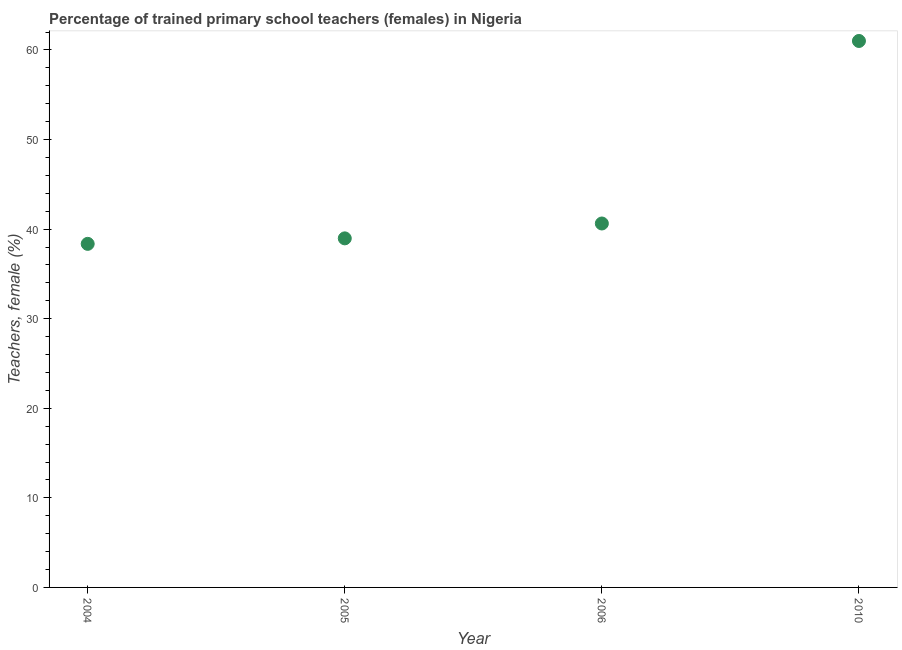What is the percentage of trained female teachers in 2005?
Ensure brevity in your answer.  38.97. Across all years, what is the maximum percentage of trained female teachers?
Offer a very short reply. 61.01. Across all years, what is the minimum percentage of trained female teachers?
Provide a short and direct response. 38.36. What is the sum of the percentage of trained female teachers?
Provide a succinct answer. 178.96. What is the difference between the percentage of trained female teachers in 2004 and 2010?
Give a very brief answer. -22.65. What is the average percentage of trained female teachers per year?
Give a very brief answer. 44.74. What is the median percentage of trained female teachers?
Keep it short and to the point. 39.8. In how many years, is the percentage of trained female teachers greater than 60 %?
Provide a short and direct response. 1. Do a majority of the years between 2004 and 2005 (inclusive) have percentage of trained female teachers greater than 12 %?
Ensure brevity in your answer.  Yes. What is the ratio of the percentage of trained female teachers in 2004 to that in 2005?
Keep it short and to the point. 0.98. Is the difference between the percentage of trained female teachers in 2005 and 2010 greater than the difference between any two years?
Offer a very short reply. No. What is the difference between the highest and the second highest percentage of trained female teachers?
Keep it short and to the point. 20.38. What is the difference between the highest and the lowest percentage of trained female teachers?
Your response must be concise. 22.65. In how many years, is the percentage of trained female teachers greater than the average percentage of trained female teachers taken over all years?
Give a very brief answer. 1. Are the values on the major ticks of Y-axis written in scientific E-notation?
Your response must be concise. No. Does the graph contain grids?
Offer a terse response. No. What is the title of the graph?
Provide a succinct answer. Percentage of trained primary school teachers (females) in Nigeria. What is the label or title of the Y-axis?
Your response must be concise. Teachers, female (%). What is the Teachers, female (%) in 2004?
Ensure brevity in your answer.  38.36. What is the Teachers, female (%) in 2005?
Make the answer very short. 38.97. What is the Teachers, female (%) in 2006?
Provide a succinct answer. 40.63. What is the Teachers, female (%) in 2010?
Your response must be concise. 61.01. What is the difference between the Teachers, female (%) in 2004 and 2005?
Your answer should be very brief. -0.61. What is the difference between the Teachers, female (%) in 2004 and 2006?
Offer a terse response. -2.27. What is the difference between the Teachers, female (%) in 2004 and 2010?
Make the answer very short. -22.65. What is the difference between the Teachers, female (%) in 2005 and 2006?
Your answer should be compact. -1.66. What is the difference between the Teachers, female (%) in 2005 and 2010?
Keep it short and to the point. -22.04. What is the difference between the Teachers, female (%) in 2006 and 2010?
Your answer should be very brief. -20.38. What is the ratio of the Teachers, female (%) in 2004 to that in 2006?
Provide a short and direct response. 0.94. What is the ratio of the Teachers, female (%) in 2004 to that in 2010?
Make the answer very short. 0.63. What is the ratio of the Teachers, female (%) in 2005 to that in 2010?
Make the answer very short. 0.64. What is the ratio of the Teachers, female (%) in 2006 to that in 2010?
Your answer should be very brief. 0.67. 